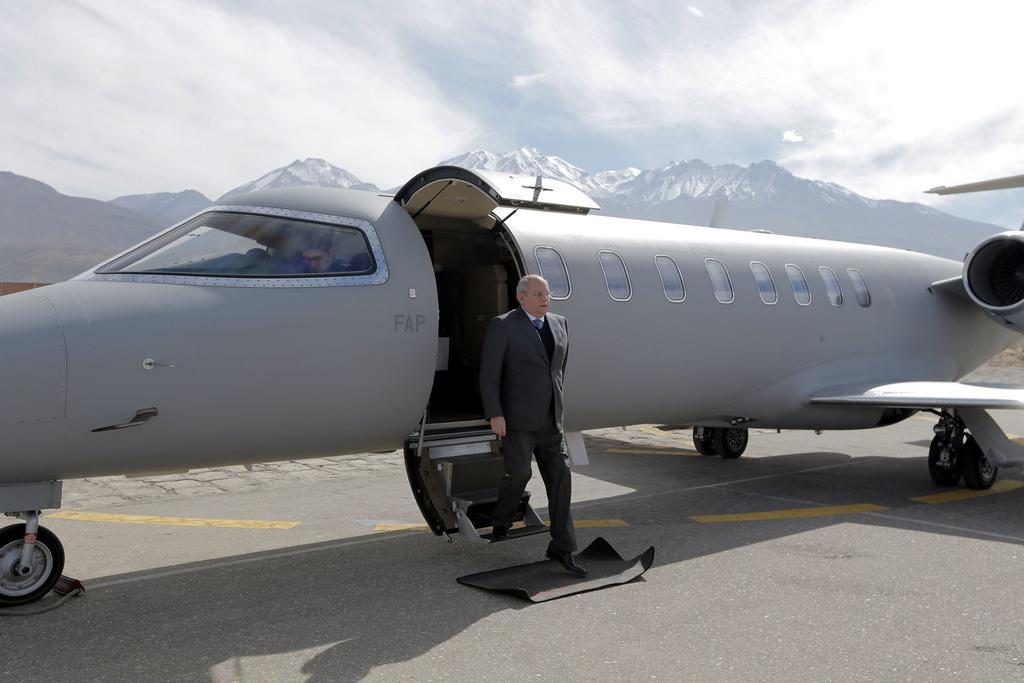What is happening with the person in the image? There is a person exiting from the plane in the image. Who is in the cockpit of the plane? There is a pilot in the cockpit of the plane. What can be seen in the distance in the image? Mountains are visible in the background of the image. What is visible above the mountains in the image? The sky is visible in the background of the image. What type of leather is being used to make the grain in the image? There is no leather or grain present in the image; it features a person exiting a plane with mountains and the sky in the background. 